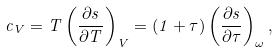<formula> <loc_0><loc_0><loc_500><loc_500>c _ { V } = T \left ( { { \frac { \partial s } { \partial T } } } \right ) _ { V } = ( 1 + \tau ) \left ( { { \frac { \partial s } { \partial \tau } } } \right ) _ { \omega } ,</formula> 